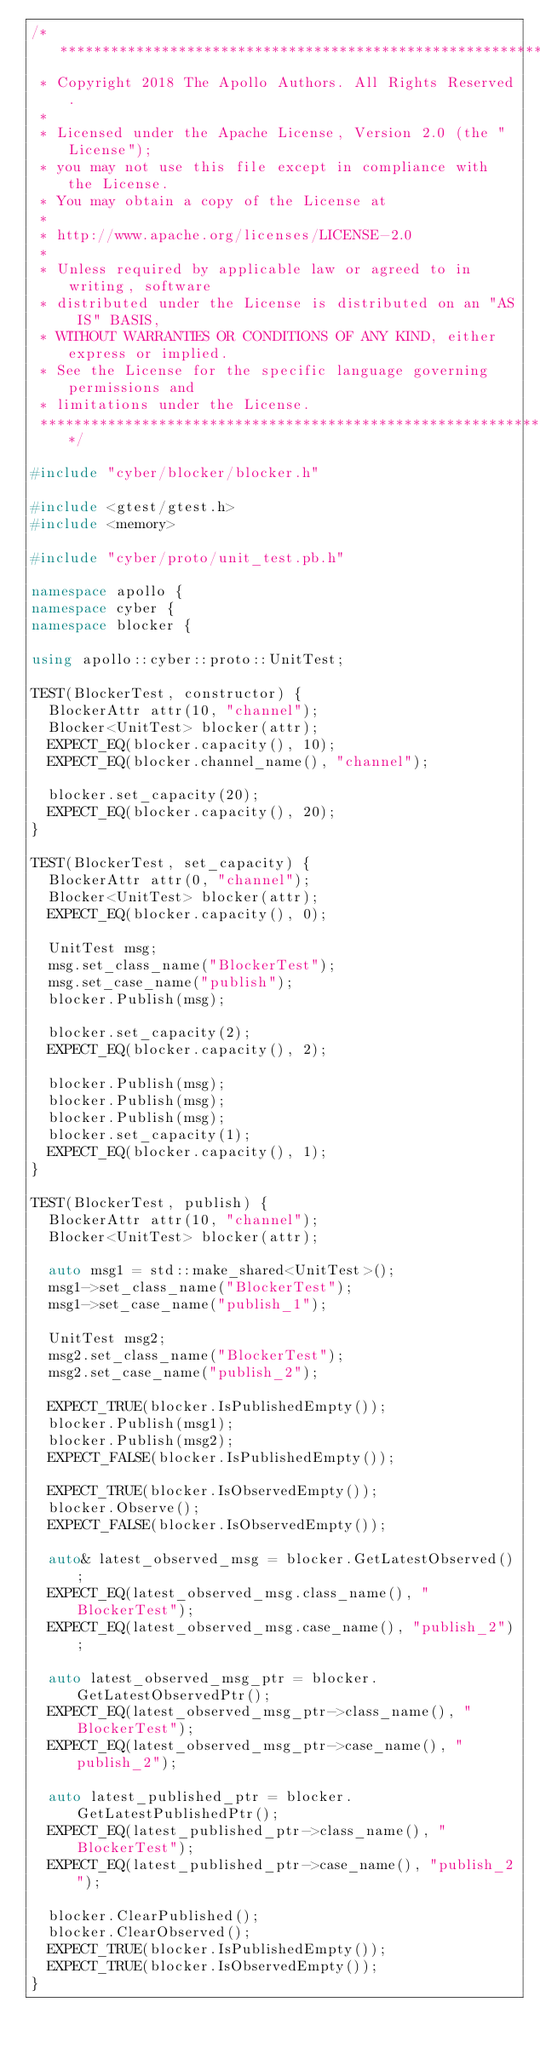<code> <loc_0><loc_0><loc_500><loc_500><_C++_>/******************************************************************************
 * Copyright 2018 The Apollo Authors. All Rights Reserved.
 *
 * Licensed under the Apache License, Version 2.0 (the "License");
 * you may not use this file except in compliance with the License.
 * You may obtain a copy of the License at
 *
 * http://www.apache.org/licenses/LICENSE-2.0
 *
 * Unless required by applicable law or agreed to in writing, software
 * distributed under the License is distributed on an "AS IS" BASIS,
 * WITHOUT WARRANTIES OR CONDITIONS OF ANY KIND, either express or implied.
 * See the License for the specific language governing permissions and
 * limitations under the License.
 *****************************************************************************/

#include "cyber/blocker/blocker.h"

#include <gtest/gtest.h>
#include <memory>

#include "cyber/proto/unit_test.pb.h"

namespace apollo {
namespace cyber {
namespace blocker {

using apollo::cyber::proto::UnitTest;

TEST(BlockerTest, constructor) {
  BlockerAttr attr(10, "channel");
  Blocker<UnitTest> blocker(attr);
  EXPECT_EQ(blocker.capacity(), 10);
  EXPECT_EQ(blocker.channel_name(), "channel");

  blocker.set_capacity(20);
  EXPECT_EQ(blocker.capacity(), 20);
}

TEST(BlockerTest, set_capacity) {
  BlockerAttr attr(0, "channel");
  Blocker<UnitTest> blocker(attr);
  EXPECT_EQ(blocker.capacity(), 0);

  UnitTest msg;
  msg.set_class_name("BlockerTest");
  msg.set_case_name("publish");
  blocker.Publish(msg);

  blocker.set_capacity(2);
  EXPECT_EQ(blocker.capacity(), 2);

  blocker.Publish(msg);
  blocker.Publish(msg);
  blocker.Publish(msg);
  blocker.set_capacity(1);
  EXPECT_EQ(blocker.capacity(), 1);
}

TEST(BlockerTest, publish) {
  BlockerAttr attr(10, "channel");
  Blocker<UnitTest> blocker(attr);

  auto msg1 = std::make_shared<UnitTest>();
  msg1->set_class_name("BlockerTest");
  msg1->set_case_name("publish_1");

  UnitTest msg2;
  msg2.set_class_name("BlockerTest");
  msg2.set_case_name("publish_2");

  EXPECT_TRUE(blocker.IsPublishedEmpty());
  blocker.Publish(msg1);
  blocker.Publish(msg2);
  EXPECT_FALSE(blocker.IsPublishedEmpty());

  EXPECT_TRUE(blocker.IsObservedEmpty());
  blocker.Observe();
  EXPECT_FALSE(blocker.IsObservedEmpty());

  auto& latest_observed_msg = blocker.GetLatestObserved();
  EXPECT_EQ(latest_observed_msg.class_name(), "BlockerTest");
  EXPECT_EQ(latest_observed_msg.case_name(), "publish_2");

  auto latest_observed_msg_ptr = blocker.GetLatestObservedPtr();
  EXPECT_EQ(latest_observed_msg_ptr->class_name(), "BlockerTest");
  EXPECT_EQ(latest_observed_msg_ptr->case_name(), "publish_2");

  auto latest_published_ptr = blocker.GetLatestPublishedPtr();
  EXPECT_EQ(latest_published_ptr->class_name(), "BlockerTest");
  EXPECT_EQ(latest_published_ptr->case_name(), "publish_2");

  blocker.ClearPublished();
  blocker.ClearObserved();
  EXPECT_TRUE(blocker.IsPublishedEmpty());
  EXPECT_TRUE(blocker.IsObservedEmpty());
}
</code> 